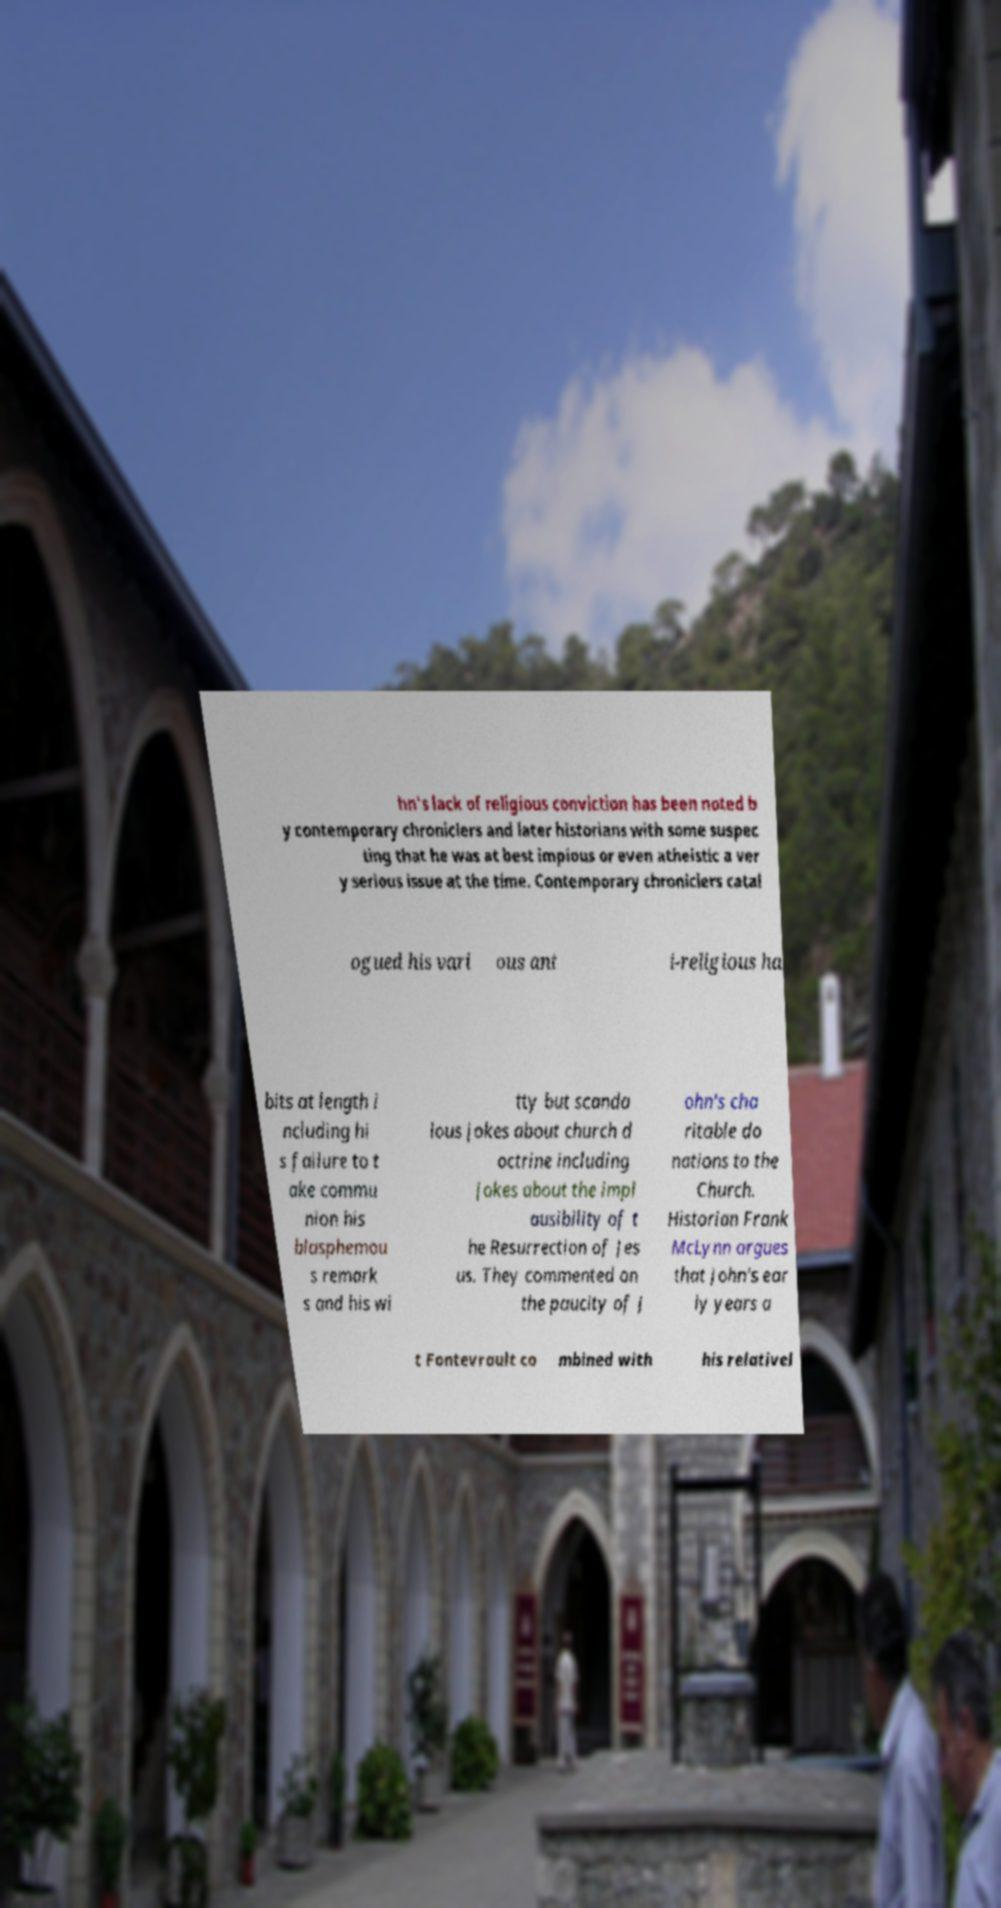Could you extract and type out the text from this image? hn's lack of religious conviction has been noted b y contemporary chroniclers and later historians with some suspec ting that he was at best impious or even atheistic a ver y serious issue at the time. Contemporary chroniclers catal ogued his vari ous ant i-religious ha bits at length i ncluding hi s failure to t ake commu nion his blasphemou s remark s and his wi tty but scanda lous jokes about church d octrine including jokes about the impl ausibility of t he Resurrection of Jes us. They commented on the paucity of J ohn's cha ritable do nations to the Church. Historian Frank McLynn argues that John's ear ly years a t Fontevrault co mbined with his relativel 